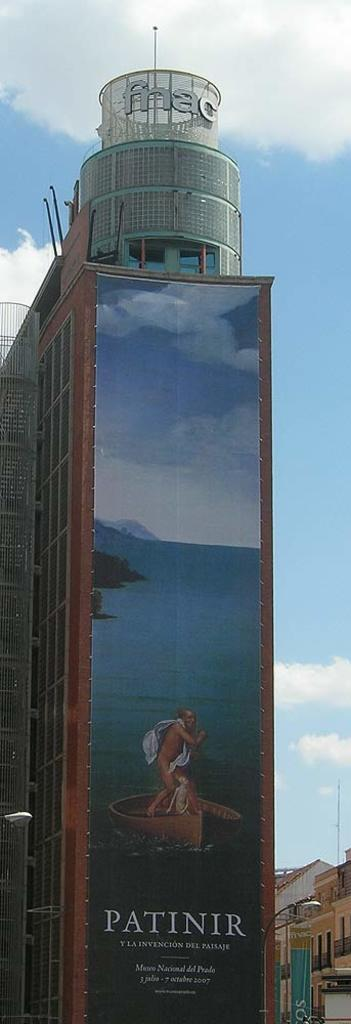What is the main structure in the center of the image? There is a skyscraper in the center of the image. What is on the skyscraper? There is a poster on the skyscraper. What else can be seen in the image besides the skyscraper? There are other buildings in the bottom right side of the image. What type of religious symbol can be seen on the poster? There is no religious symbol present on the poster in the image. How does the pain affect the appearance of the skyscraper in the image? There is no mention of pain in the image, and the skyscraper appears normal. 